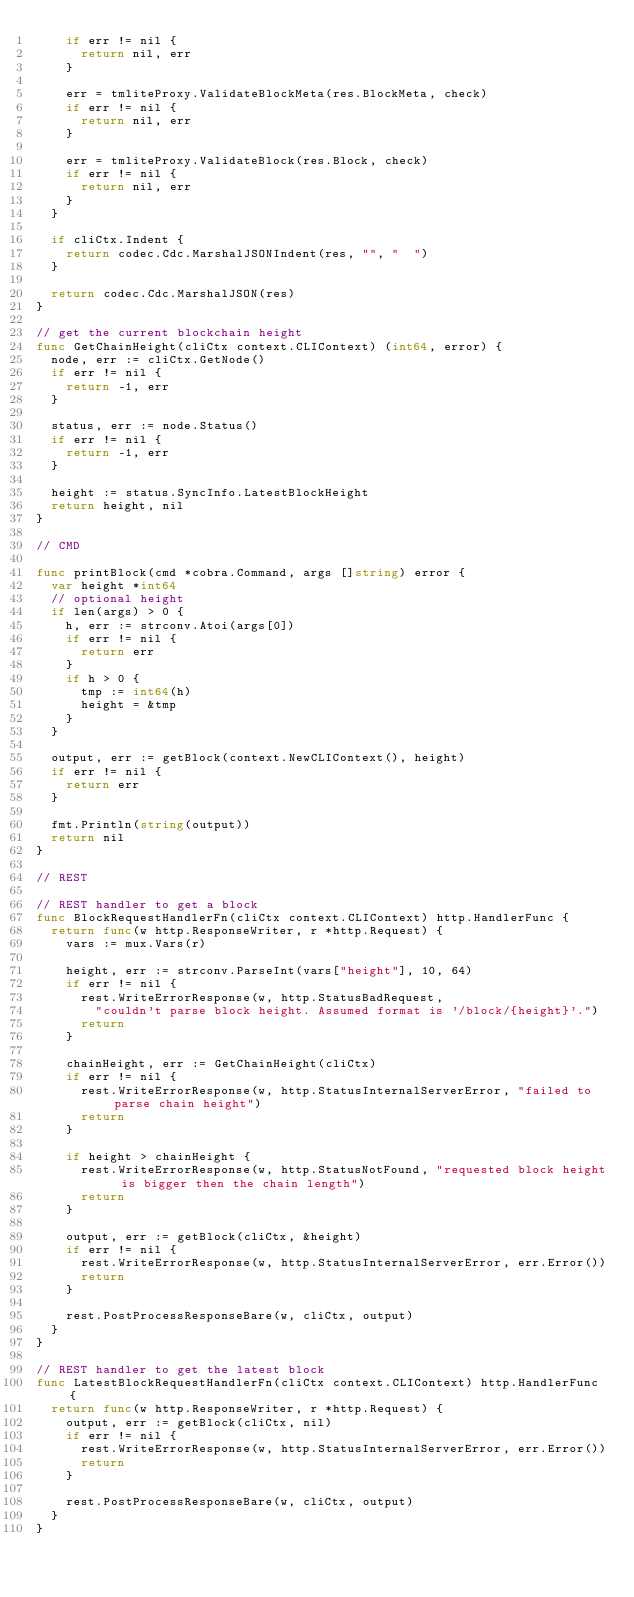Convert code to text. <code><loc_0><loc_0><loc_500><loc_500><_Go_>		if err != nil {
			return nil, err
		}

		err = tmliteProxy.ValidateBlockMeta(res.BlockMeta, check)
		if err != nil {
			return nil, err
		}

		err = tmliteProxy.ValidateBlock(res.Block, check)
		if err != nil {
			return nil, err
		}
	}

	if cliCtx.Indent {
		return codec.Cdc.MarshalJSONIndent(res, "", "  ")
	}

	return codec.Cdc.MarshalJSON(res)
}

// get the current blockchain height
func GetChainHeight(cliCtx context.CLIContext) (int64, error) {
	node, err := cliCtx.GetNode()
	if err != nil {
		return -1, err
	}

	status, err := node.Status()
	if err != nil {
		return -1, err
	}

	height := status.SyncInfo.LatestBlockHeight
	return height, nil
}

// CMD

func printBlock(cmd *cobra.Command, args []string) error {
	var height *int64
	// optional height
	if len(args) > 0 {
		h, err := strconv.Atoi(args[0])
		if err != nil {
			return err
		}
		if h > 0 {
			tmp := int64(h)
			height = &tmp
		}
	}

	output, err := getBlock(context.NewCLIContext(), height)
	if err != nil {
		return err
	}

	fmt.Println(string(output))
	return nil
}

// REST

// REST handler to get a block
func BlockRequestHandlerFn(cliCtx context.CLIContext) http.HandlerFunc {
	return func(w http.ResponseWriter, r *http.Request) {
		vars := mux.Vars(r)

		height, err := strconv.ParseInt(vars["height"], 10, 64)
		if err != nil {
			rest.WriteErrorResponse(w, http.StatusBadRequest,
				"couldn't parse block height. Assumed format is '/block/{height}'.")
			return
		}

		chainHeight, err := GetChainHeight(cliCtx)
		if err != nil {
			rest.WriteErrorResponse(w, http.StatusInternalServerError, "failed to parse chain height")
			return
		}

		if height > chainHeight {
			rest.WriteErrorResponse(w, http.StatusNotFound, "requested block height is bigger then the chain length")
			return
		}

		output, err := getBlock(cliCtx, &height)
		if err != nil {
			rest.WriteErrorResponse(w, http.StatusInternalServerError, err.Error())
			return
		}

		rest.PostProcessResponseBare(w, cliCtx, output)
	}
}

// REST handler to get the latest block
func LatestBlockRequestHandlerFn(cliCtx context.CLIContext) http.HandlerFunc {
	return func(w http.ResponseWriter, r *http.Request) {
		output, err := getBlock(cliCtx, nil)
		if err != nil {
			rest.WriteErrorResponse(w, http.StatusInternalServerError, err.Error())
			return
		}

		rest.PostProcessResponseBare(w, cliCtx, output)
	}
}
</code> 